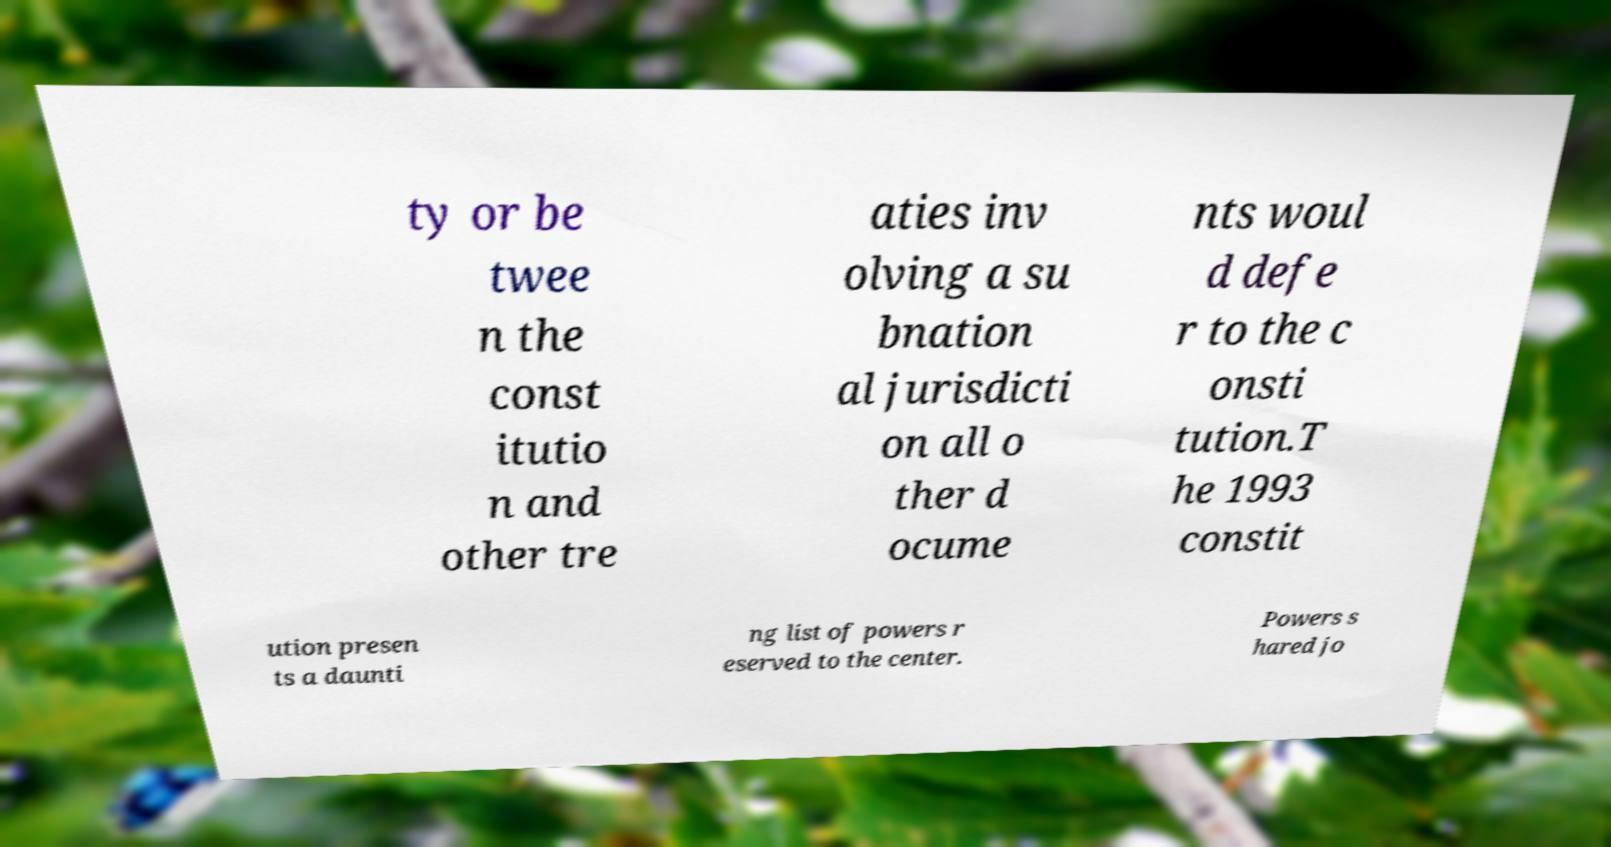For documentation purposes, I need the text within this image transcribed. Could you provide that? ty or be twee n the const itutio n and other tre aties inv olving a su bnation al jurisdicti on all o ther d ocume nts woul d defe r to the c onsti tution.T he 1993 constit ution presen ts a daunti ng list of powers r eserved to the center. Powers s hared jo 